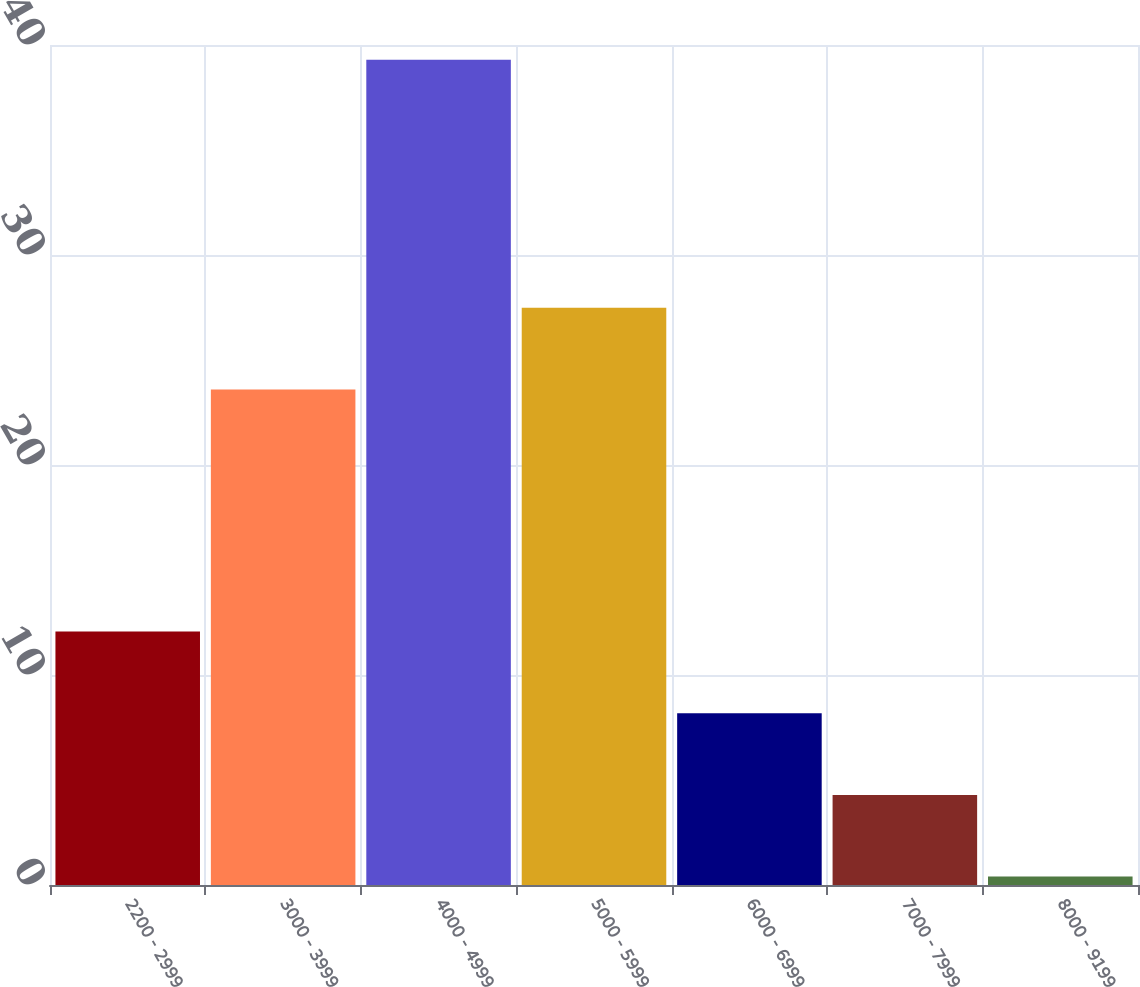Convert chart to OTSL. <chart><loc_0><loc_0><loc_500><loc_500><bar_chart><fcel>2200 - 2999<fcel>3000 - 3999<fcel>4000 - 4999<fcel>5000 - 5999<fcel>6000 - 6999<fcel>7000 - 7999<fcel>8000 - 9199<nl><fcel>12.07<fcel>23.6<fcel>39.3<fcel>27.49<fcel>8.18<fcel>4.29<fcel>0.4<nl></chart> 